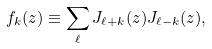<formula> <loc_0><loc_0><loc_500><loc_500>f _ { k } ( z ) \equiv \sum _ { \ell } J _ { \ell + k } ( z ) J _ { \ell - k } ( z ) ,</formula> 